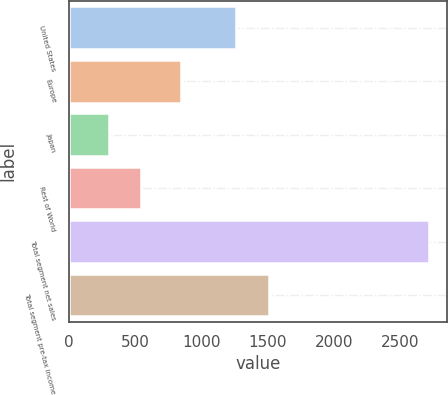Convert chart to OTSL. <chart><loc_0><loc_0><loc_500><loc_500><bar_chart><fcel>United States<fcel>Europe<fcel>Japan<fcel>Rest of World<fcel>Total segment net sales<fcel>Total segment pre-tax income<nl><fcel>1262.8<fcel>842.9<fcel>297.2<fcel>539.28<fcel>2718<fcel>1504.88<nl></chart> 